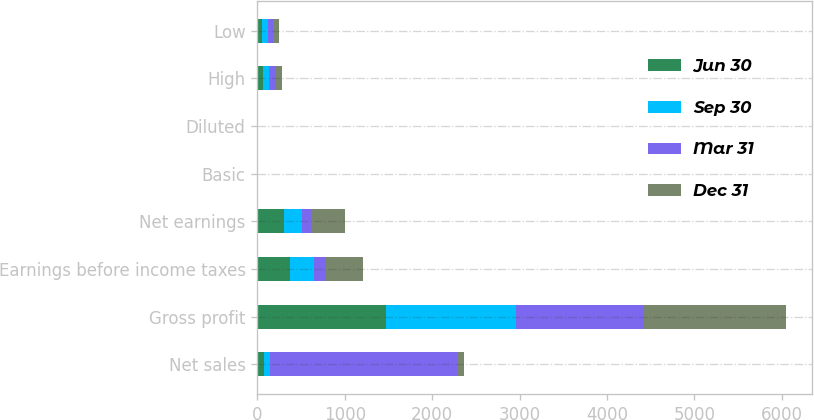<chart> <loc_0><loc_0><loc_500><loc_500><stacked_bar_chart><ecel><fcel>Net sales<fcel>Gross profit<fcel>Earnings before income taxes<fcel>Net earnings<fcel>Basic<fcel>Diluted<fcel>High<fcel>Low<nl><fcel>Jun 30<fcel>71.94<fcel>1477<fcel>375<fcel>304<fcel>0.8<fcel>0.79<fcel>66.92<fcel>55.24<nl><fcel>Sep 30<fcel>71.94<fcel>1482<fcel>269<fcel>213<fcel>0.56<fcel>0.56<fcel>70<fcel>63.35<nl><fcel>Mar 31<fcel>2151<fcel>1469<fcel>137<fcel>103<fcel>0.27<fcel>0.27<fcel>71.94<fcel>63.71<nl><fcel>Dec 31<fcel>71.94<fcel>1616<fcel>431<fcel>386<fcel>1.02<fcel>1.01<fcel>75.55<fcel>66.93<nl></chart> 